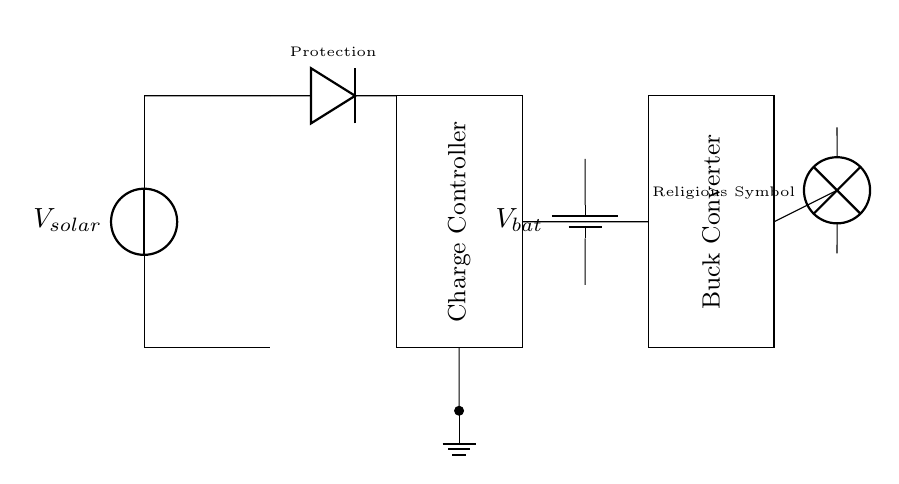What component is used for protection in this circuit? The diode serves as a protection component to prevent current from flowing backward and to safeguard the circuit from potential damage due to reverse polarity.
Answer: diode What does the charge controller do? The charge controller regulates the voltage and current from the solar panel to ensure that the battery is charged properly, preventing overcharging and enhancing battery life.
Answer: Charge Controller How many main components are present in this circuit? The circuit consists of five main components: a solar panel, a diode, a charge controller, a battery, and a buck converter.
Answer: five What is the purpose of the buck converter in this circuit? The buck converter steps down the voltage from the battery to a lower voltage suitable for operating the load, which in this case is the religious symbol.
Answer: Buck Converter What does the output represent in this circuit? The output of the circuit connects to a lamp labeled as "Religious Symbol," indicating that it is the load receiving power from the circuit to light up the artifact.
Answer: Religious Symbol Where is the ground connection located in the circuit? The ground connection is marked at the bottom of the charge controller, connecting to the ground node, which serves as a reference point for the voltages in the circuit.
Answer: Ground What is the voltage source used in the circuit? The voltage source provided by the solar panel is denoted as "V_solar," which represents the energy harnessed from sunlight to power the circuit.
Answer: V_solar 